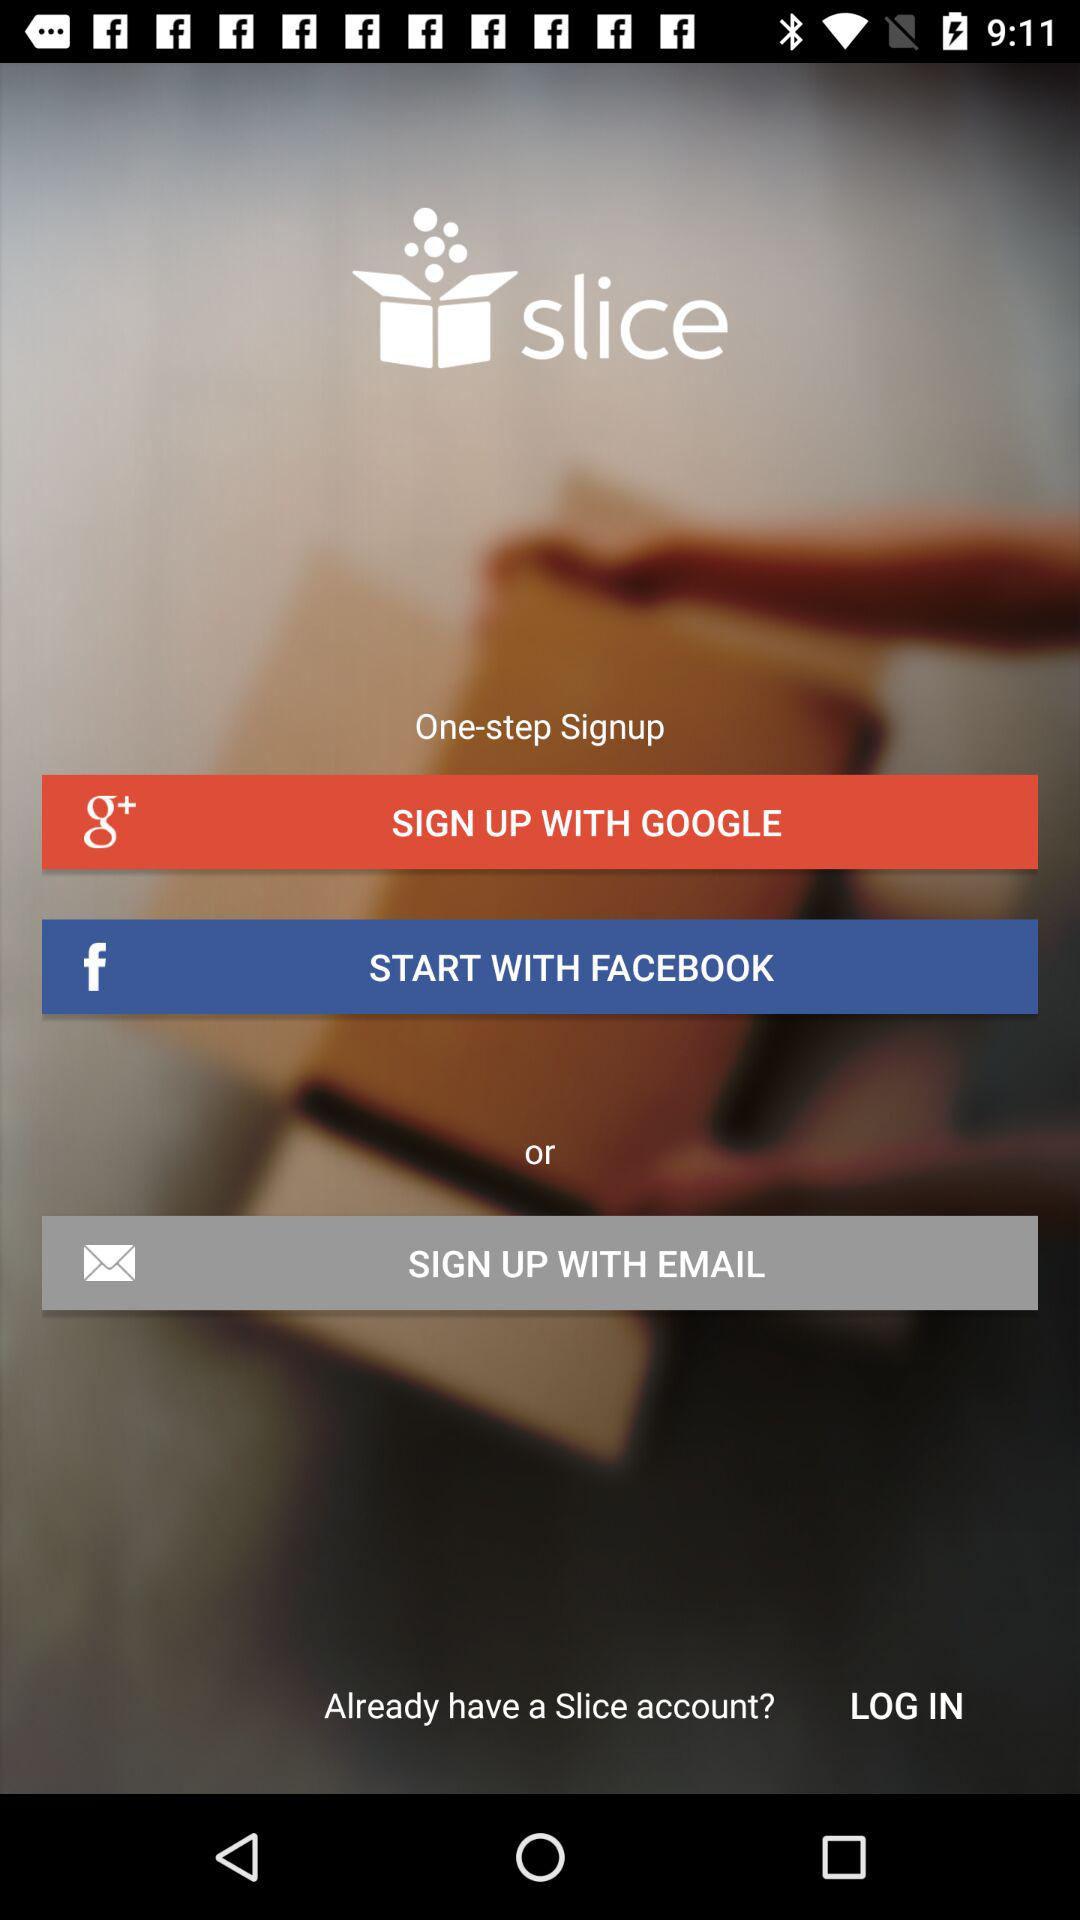What is the app name? The app name is "slice". 